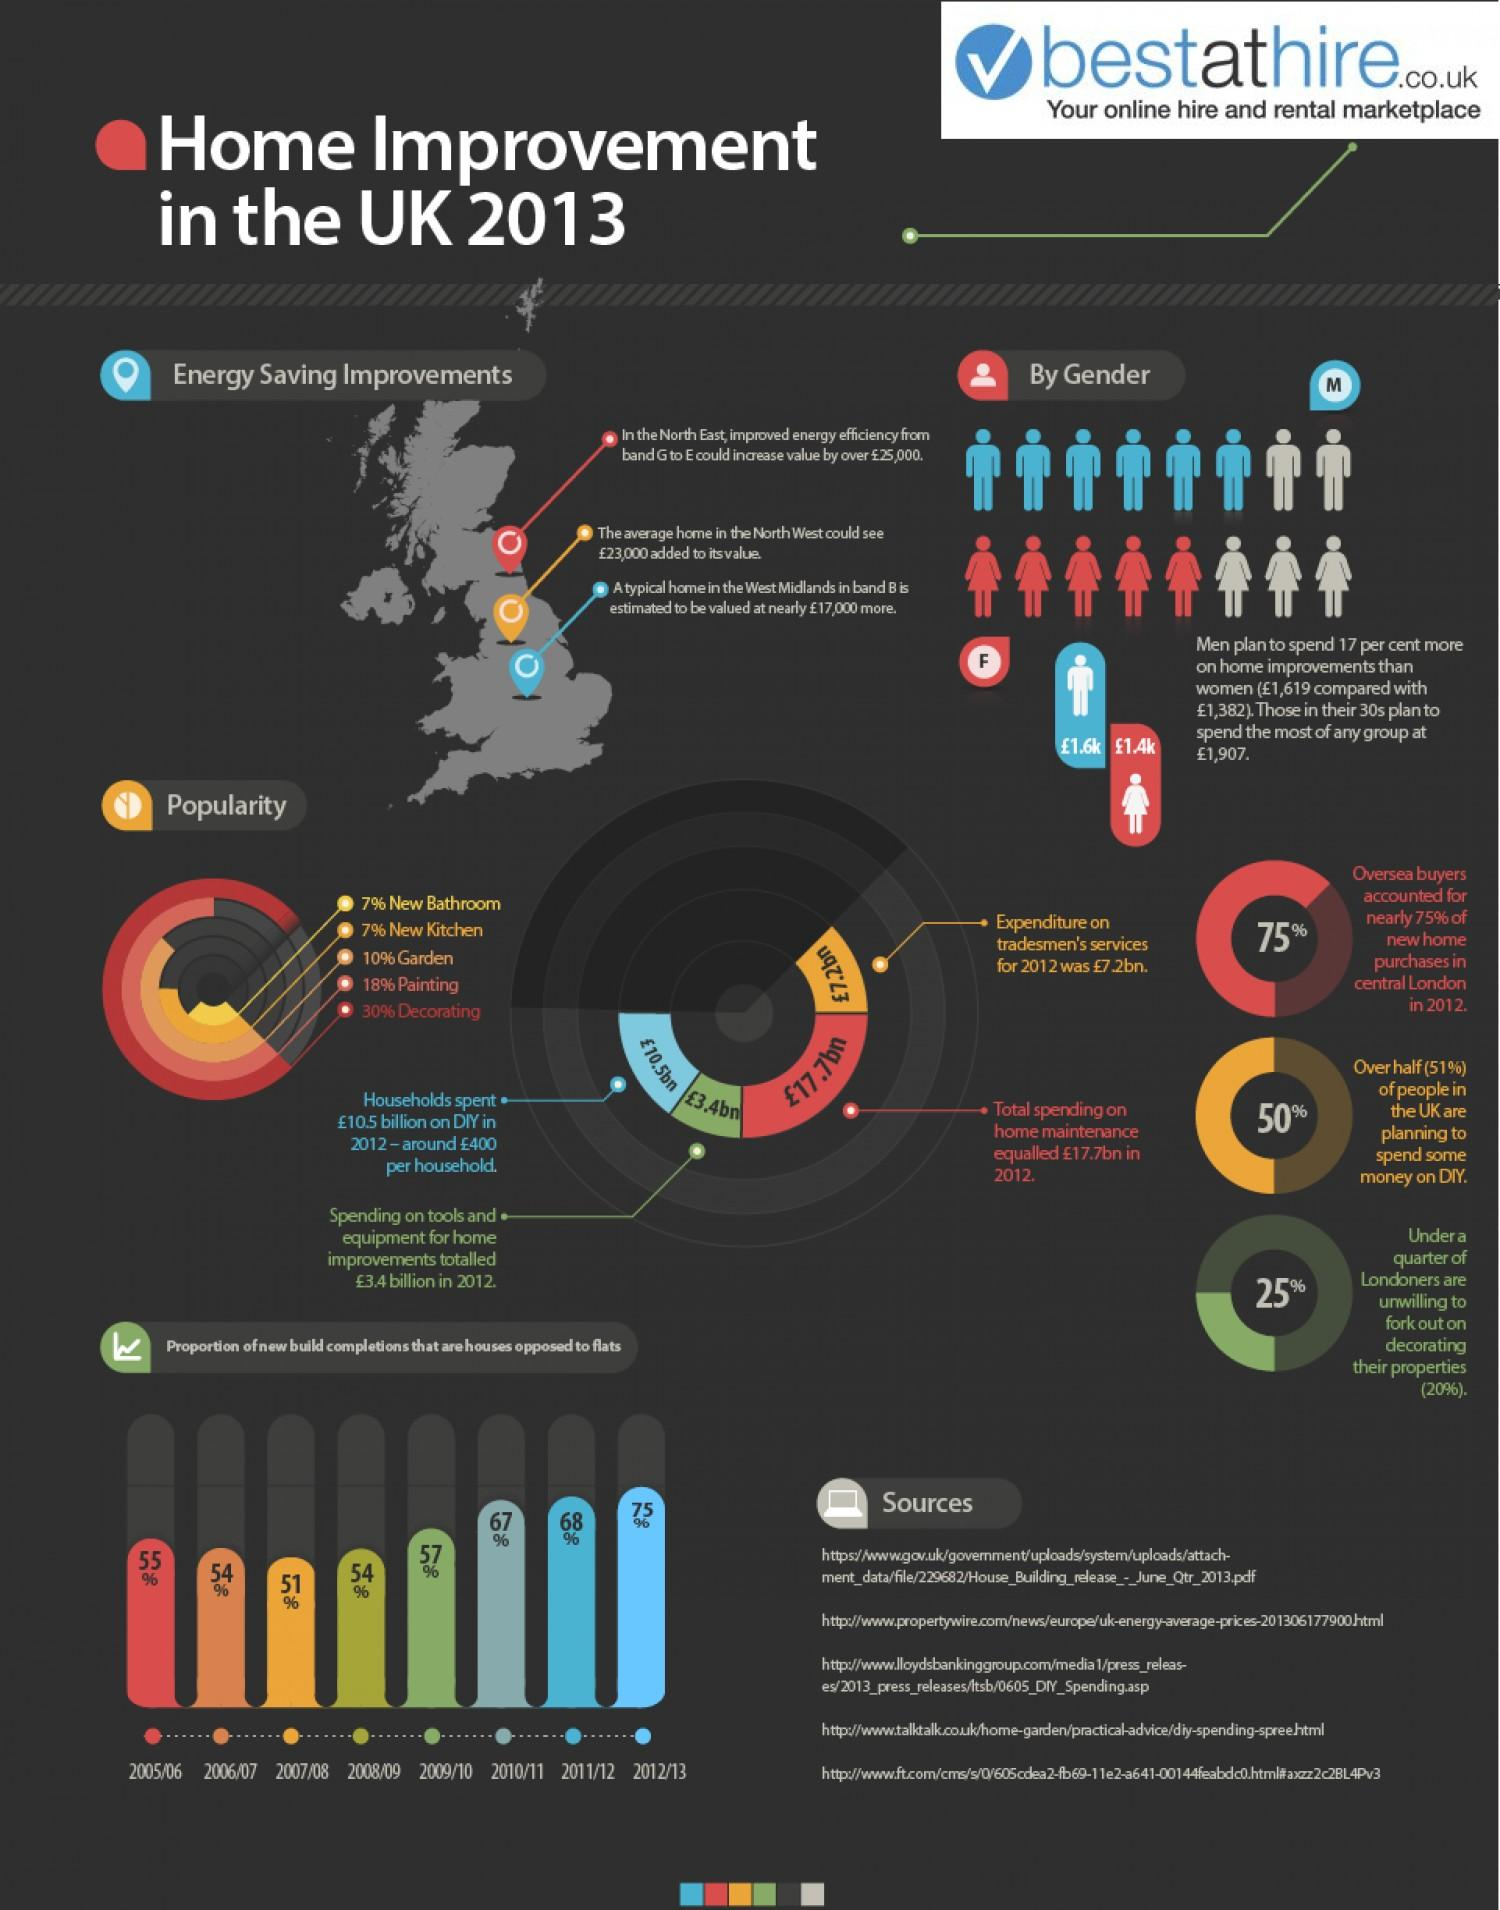Draw attention to some important aspects in this diagram. In London, over 75% of residents are willing to invest in decorating their properties, indicating a strong demand for home improvement services. Only a small percentage of under 25% of Londoners are hesitant to spend money on home decorating, highlighting a potential opportunity for businesses that specialize in this area. Decorating is the most commonly done home improvement task in homes. The average amount spent by women on home improvements is approximately 1,382 pounds. In 2020, it was reported that 75% of new home purchases were made by overseas buyers. In 2012, a total of 7.2 billion pounds was spent on tradesmen's services in the United Kingdom. 